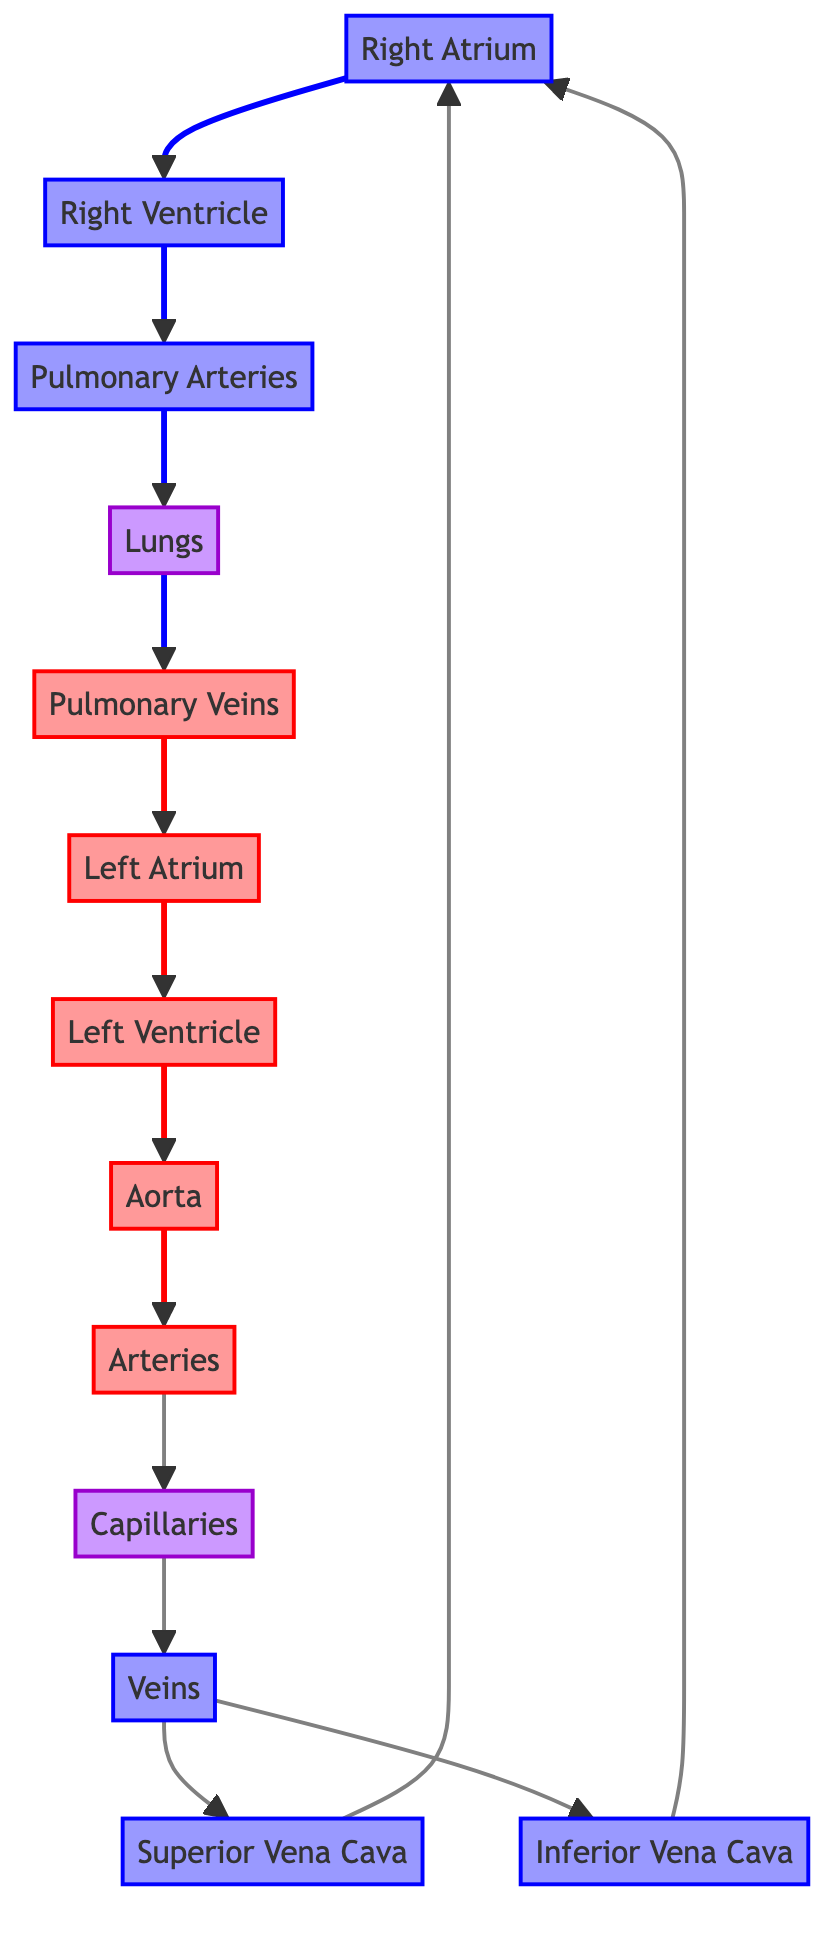What is the first chamber of the heart that blood enters? Blood enters the right atrium first after returning from the body through the superior and inferior vena cava.
Answer: Right Atrium What type of blood do the pulmonary veins carry? The pulmonary veins carry oxygenated blood as they transport it from the lungs back to the left atrium of the heart.
Answer: Oxygenated What does the capillary exchange mainly facilitate? Capillaries facilitate the exchange of gases, nutrients, and wastes between blood and tissues.
Answer: Exchange How many nodes are present in the diagram? There are a total of 10 nodes representing different components of the circulatory system.
Answer: 10 Which vessel carries deoxygenated blood from the heart to the lungs? The pulmonary arteries carry deoxygenated blood from the right ventricle to the lungs for oxygenation.
Answer: Pulmonary Arteries What is the final destination of oxygenated blood in this diagram? The final destination of oxygenated blood is the aorta, which distributes it to the rest of the body.
Answer: Aorta How do veins receive blood from the capillaries? Veins collect deoxygenated blood from the capillaries and carry it back towards the heart.
Answer: Through Veins Which chamber does the left ventricle send blood to? The left ventricle sends oxygenated blood to the aorta for distribution throughout the body.
Answer: Aorta What type of blood do the pulmonary arteries carry? The pulmonary arteries carry deoxygenated blood from the right ventricle to the lungs.
Answer: Deoxygenated 